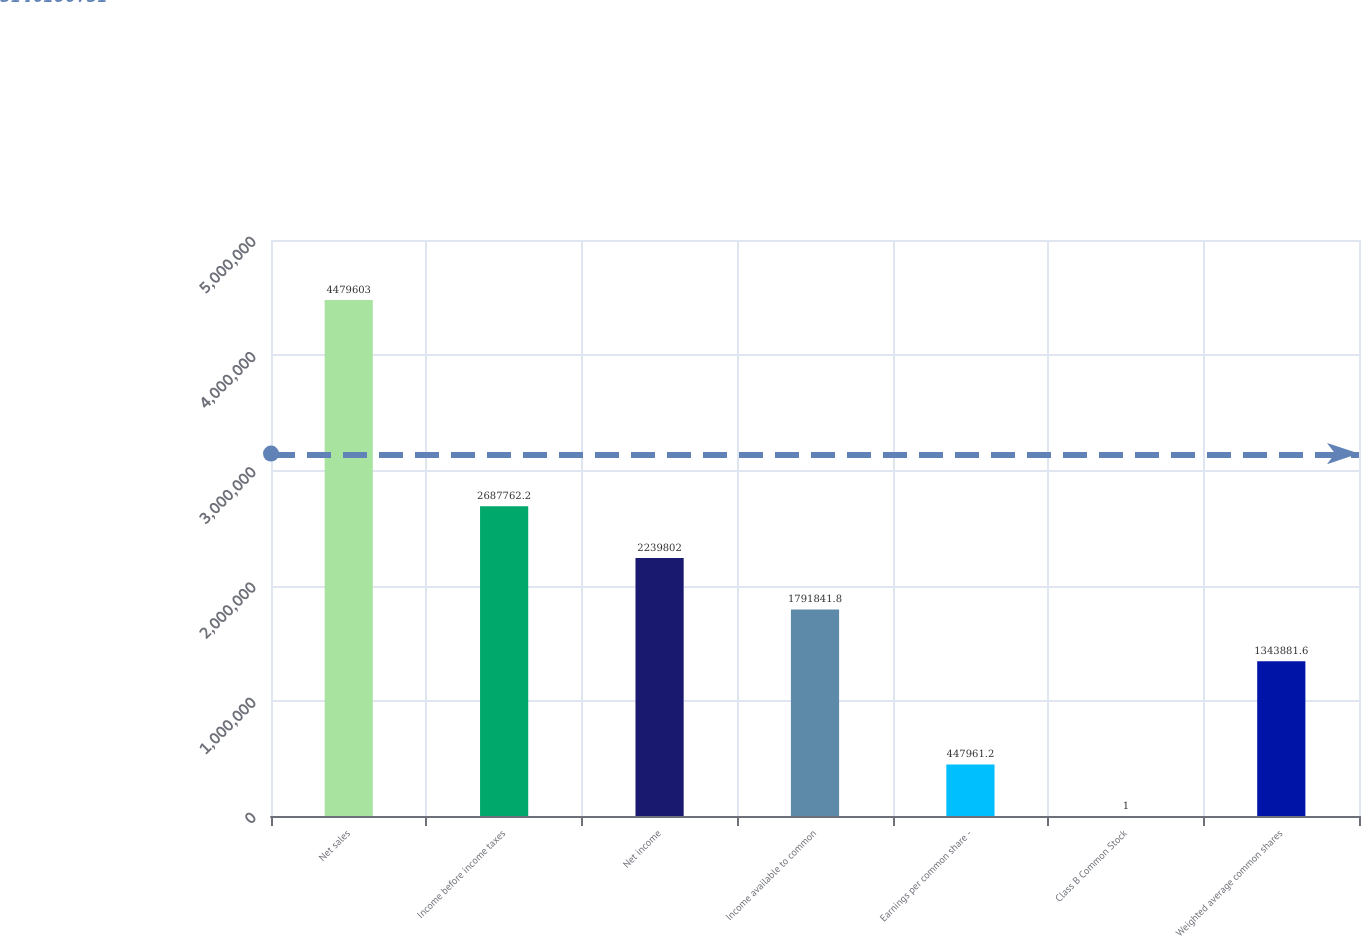Convert chart. <chart><loc_0><loc_0><loc_500><loc_500><bar_chart><fcel>Net sales<fcel>Income before income taxes<fcel>Net income<fcel>Income available to common<fcel>Earnings per common share -<fcel>Class B Common Stock<fcel>Weighted average common shares<nl><fcel>4.4796e+06<fcel>2.68776e+06<fcel>2.2398e+06<fcel>1.79184e+06<fcel>447961<fcel>1<fcel>1.34388e+06<nl></chart> 